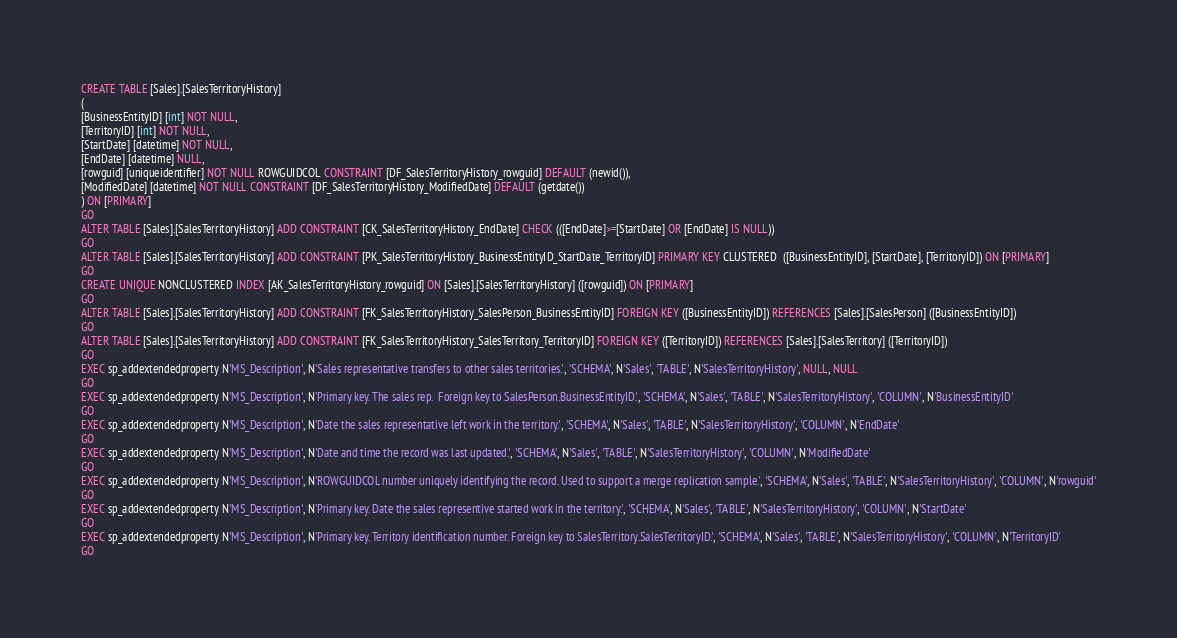Convert code to text. <code><loc_0><loc_0><loc_500><loc_500><_SQL_>CREATE TABLE [Sales].[SalesTerritoryHistory]
(
[BusinessEntityID] [int] NOT NULL,
[TerritoryID] [int] NOT NULL,
[StartDate] [datetime] NOT NULL,
[EndDate] [datetime] NULL,
[rowguid] [uniqueidentifier] NOT NULL ROWGUIDCOL CONSTRAINT [DF_SalesTerritoryHistory_rowguid] DEFAULT (newid()),
[ModifiedDate] [datetime] NOT NULL CONSTRAINT [DF_SalesTerritoryHistory_ModifiedDate] DEFAULT (getdate())
) ON [PRIMARY]
GO
ALTER TABLE [Sales].[SalesTerritoryHistory] ADD CONSTRAINT [CK_SalesTerritoryHistory_EndDate] CHECK (([EndDate]>=[StartDate] OR [EndDate] IS NULL))
GO
ALTER TABLE [Sales].[SalesTerritoryHistory] ADD CONSTRAINT [PK_SalesTerritoryHistory_BusinessEntityID_StartDate_TerritoryID] PRIMARY KEY CLUSTERED  ([BusinessEntityID], [StartDate], [TerritoryID]) ON [PRIMARY]
GO
CREATE UNIQUE NONCLUSTERED INDEX [AK_SalesTerritoryHistory_rowguid] ON [Sales].[SalesTerritoryHistory] ([rowguid]) ON [PRIMARY]
GO
ALTER TABLE [Sales].[SalesTerritoryHistory] ADD CONSTRAINT [FK_SalesTerritoryHistory_SalesPerson_BusinessEntityID] FOREIGN KEY ([BusinessEntityID]) REFERENCES [Sales].[SalesPerson] ([BusinessEntityID])
GO
ALTER TABLE [Sales].[SalesTerritoryHistory] ADD CONSTRAINT [FK_SalesTerritoryHistory_SalesTerritory_TerritoryID] FOREIGN KEY ([TerritoryID]) REFERENCES [Sales].[SalesTerritory] ([TerritoryID])
GO
EXEC sp_addextendedproperty N'MS_Description', N'Sales representative transfers to other sales territories.', 'SCHEMA', N'Sales', 'TABLE', N'SalesTerritoryHistory', NULL, NULL
GO
EXEC sp_addextendedproperty N'MS_Description', N'Primary key. The sales rep.  Foreign key to SalesPerson.BusinessEntityID.', 'SCHEMA', N'Sales', 'TABLE', N'SalesTerritoryHistory', 'COLUMN', N'BusinessEntityID'
GO
EXEC sp_addextendedproperty N'MS_Description', N'Date the sales representative left work in the territory.', 'SCHEMA', N'Sales', 'TABLE', N'SalesTerritoryHistory', 'COLUMN', N'EndDate'
GO
EXEC sp_addextendedproperty N'MS_Description', N'Date and time the record was last updated.', 'SCHEMA', N'Sales', 'TABLE', N'SalesTerritoryHistory', 'COLUMN', N'ModifiedDate'
GO
EXEC sp_addextendedproperty N'MS_Description', N'ROWGUIDCOL number uniquely identifying the record. Used to support a merge replication sample.', 'SCHEMA', N'Sales', 'TABLE', N'SalesTerritoryHistory', 'COLUMN', N'rowguid'
GO
EXEC sp_addextendedproperty N'MS_Description', N'Primary key. Date the sales representive started work in the territory.', 'SCHEMA', N'Sales', 'TABLE', N'SalesTerritoryHistory', 'COLUMN', N'StartDate'
GO
EXEC sp_addextendedproperty N'MS_Description', N'Primary key. Territory identification number. Foreign key to SalesTerritory.SalesTerritoryID.', 'SCHEMA', N'Sales', 'TABLE', N'SalesTerritoryHistory', 'COLUMN', N'TerritoryID'
GO</code> 